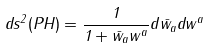Convert formula to latex. <formula><loc_0><loc_0><loc_500><loc_500>d s ^ { 2 } ( P H ) = \frac { 1 } { 1 + \bar { w } _ { a } w ^ { a } } d \bar { w } _ { a } d w ^ { a }</formula> 